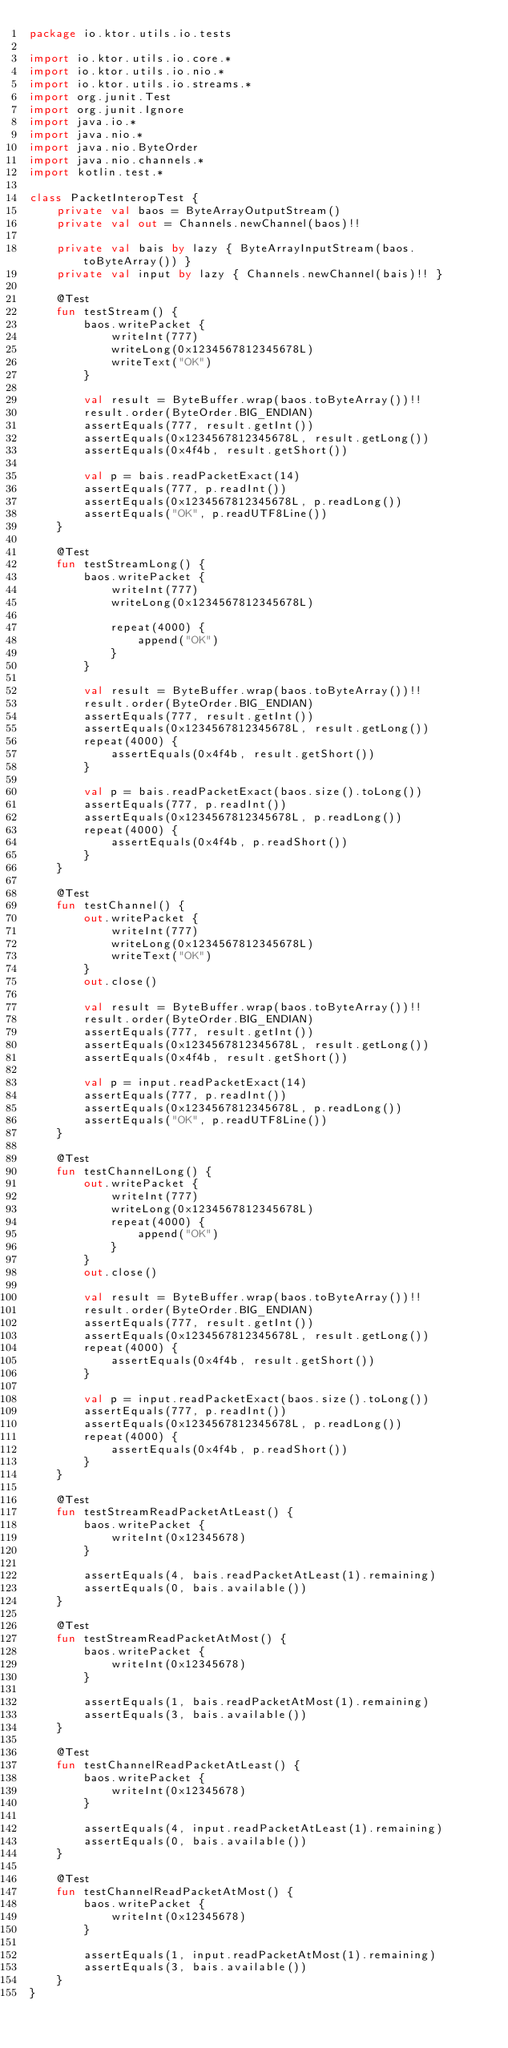<code> <loc_0><loc_0><loc_500><loc_500><_Kotlin_>package io.ktor.utils.io.tests

import io.ktor.utils.io.core.*
import io.ktor.utils.io.nio.*
import io.ktor.utils.io.streams.*
import org.junit.Test
import org.junit.Ignore
import java.io.*
import java.nio.*
import java.nio.ByteOrder
import java.nio.channels.*
import kotlin.test.*

class PacketInteropTest {
    private val baos = ByteArrayOutputStream()
    private val out = Channels.newChannel(baos)!!

    private val bais by lazy { ByteArrayInputStream(baos.toByteArray()) }
    private val input by lazy { Channels.newChannel(bais)!! }

    @Test
    fun testStream() {
        baos.writePacket {
            writeInt(777)
            writeLong(0x1234567812345678L)
            writeText("OK")
        }

        val result = ByteBuffer.wrap(baos.toByteArray())!!
        result.order(ByteOrder.BIG_ENDIAN)
        assertEquals(777, result.getInt())
        assertEquals(0x1234567812345678L, result.getLong())
        assertEquals(0x4f4b, result.getShort())

        val p = bais.readPacketExact(14)
        assertEquals(777, p.readInt())
        assertEquals(0x1234567812345678L, p.readLong())
        assertEquals("OK", p.readUTF8Line())
    }

    @Test
    fun testStreamLong() {
        baos.writePacket {
            writeInt(777)
            writeLong(0x1234567812345678L)

            repeat(4000) {
                append("OK")
            }
        }

        val result = ByteBuffer.wrap(baos.toByteArray())!!
        result.order(ByteOrder.BIG_ENDIAN)
        assertEquals(777, result.getInt())
        assertEquals(0x1234567812345678L, result.getLong())
        repeat(4000) {
            assertEquals(0x4f4b, result.getShort())
        }

        val p = bais.readPacketExact(baos.size().toLong())
        assertEquals(777, p.readInt())
        assertEquals(0x1234567812345678L, p.readLong())
        repeat(4000) {
            assertEquals(0x4f4b, p.readShort())
        }
    }

    @Test
    fun testChannel() {
        out.writePacket {
            writeInt(777)
            writeLong(0x1234567812345678L)
            writeText("OK")
        }
        out.close()

        val result = ByteBuffer.wrap(baos.toByteArray())!!
        result.order(ByteOrder.BIG_ENDIAN)
        assertEquals(777, result.getInt())
        assertEquals(0x1234567812345678L, result.getLong())
        assertEquals(0x4f4b, result.getShort())

        val p = input.readPacketExact(14)
        assertEquals(777, p.readInt())
        assertEquals(0x1234567812345678L, p.readLong())
        assertEquals("OK", p.readUTF8Line())
    }

    @Test
    fun testChannelLong() {
        out.writePacket {
            writeInt(777)
            writeLong(0x1234567812345678L)
            repeat(4000) {
                append("OK")
            }
        }
        out.close()

        val result = ByteBuffer.wrap(baos.toByteArray())!!
        result.order(ByteOrder.BIG_ENDIAN)
        assertEquals(777, result.getInt())
        assertEquals(0x1234567812345678L, result.getLong())
        repeat(4000) {
            assertEquals(0x4f4b, result.getShort())
        }

        val p = input.readPacketExact(baos.size().toLong())
        assertEquals(777, p.readInt())
        assertEquals(0x1234567812345678L, p.readLong())
        repeat(4000) {
            assertEquals(0x4f4b, p.readShort())
        }
    }

    @Test
    fun testStreamReadPacketAtLeast() {
        baos.writePacket {
            writeInt(0x12345678)
        }

        assertEquals(4, bais.readPacketAtLeast(1).remaining)
        assertEquals(0, bais.available())
    }

    @Test
    fun testStreamReadPacketAtMost() {
        baos.writePacket {
            writeInt(0x12345678)
        }

        assertEquals(1, bais.readPacketAtMost(1).remaining)
        assertEquals(3, bais.available())
    }

    @Test
    fun testChannelReadPacketAtLeast() {
        baos.writePacket {
            writeInt(0x12345678)
        }

        assertEquals(4, input.readPacketAtLeast(1).remaining)
        assertEquals(0, bais.available())
    }

    @Test
    fun testChannelReadPacketAtMost() {
        baos.writePacket {
            writeInt(0x12345678)
        }

        assertEquals(1, input.readPacketAtMost(1).remaining)
        assertEquals(3, bais.available())
    }
}
</code> 